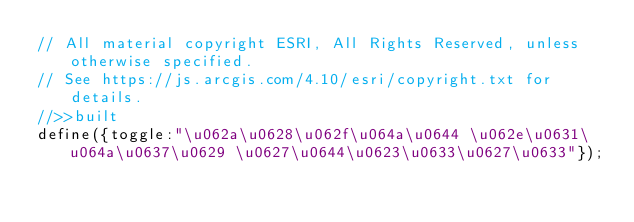<code> <loc_0><loc_0><loc_500><loc_500><_JavaScript_>// All material copyright ESRI, All Rights Reserved, unless otherwise specified.
// See https://js.arcgis.com/4.10/esri/copyright.txt for details.
//>>built
define({toggle:"\u062a\u0628\u062f\u064a\u0644 \u062e\u0631\u064a\u0637\u0629 \u0627\u0644\u0623\u0633\u0627\u0633"});</code> 